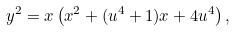<formula> <loc_0><loc_0><loc_500><loc_500>y ^ { 2 } = x \left ( x ^ { 2 } + ( u ^ { 4 } + 1 ) x + 4 u ^ { 4 } \right ) ,</formula> 